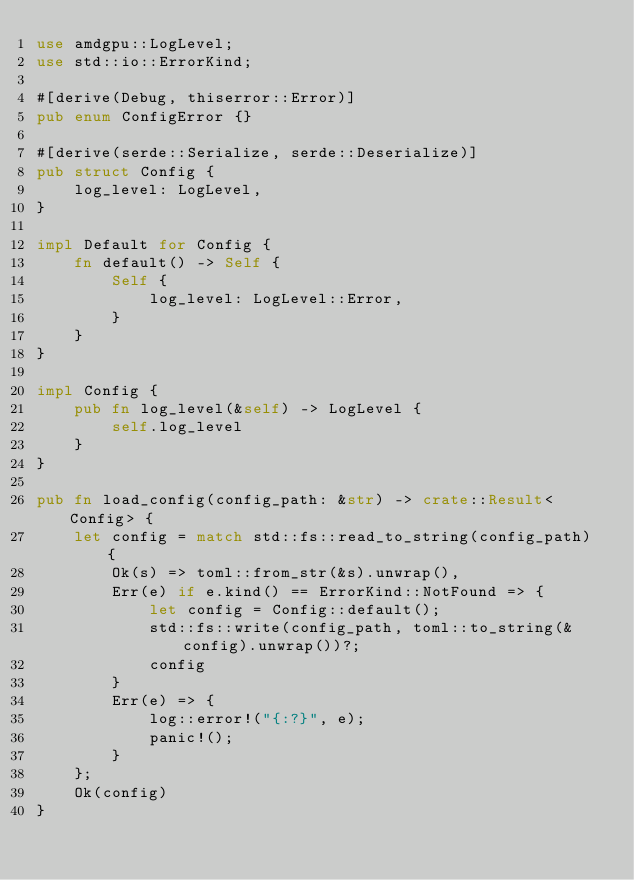Convert code to text. <code><loc_0><loc_0><loc_500><loc_500><_Rust_>use amdgpu::LogLevel;
use std::io::ErrorKind;

#[derive(Debug, thiserror::Error)]
pub enum ConfigError {}

#[derive(serde::Serialize, serde::Deserialize)]
pub struct Config {
    log_level: LogLevel,
}

impl Default for Config {
    fn default() -> Self {
        Self {
            log_level: LogLevel::Error,
        }
    }
}

impl Config {
    pub fn log_level(&self) -> LogLevel {
        self.log_level
    }
}

pub fn load_config(config_path: &str) -> crate::Result<Config> {
    let config = match std::fs::read_to_string(config_path) {
        Ok(s) => toml::from_str(&s).unwrap(),
        Err(e) if e.kind() == ErrorKind::NotFound => {
            let config = Config::default();
            std::fs::write(config_path, toml::to_string(&config).unwrap())?;
            config
        }
        Err(e) => {
            log::error!("{:?}", e);
            panic!();
        }
    };
    Ok(config)
}
</code> 